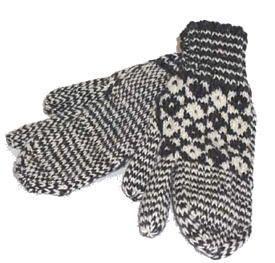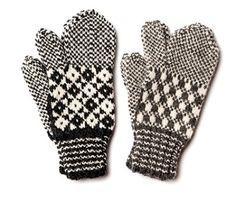The first image is the image on the left, the second image is the image on the right. Considering the images on both sides, is "Only the right image shows mittens with a diamond pattern." valid? Answer yes or no. No. 